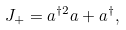<formula> <loc_0><loc_0><loc_500><loc_500>J _ { + } = a ^ { \dagger 2 } a + a ^ { \dagger } ,</formula> 